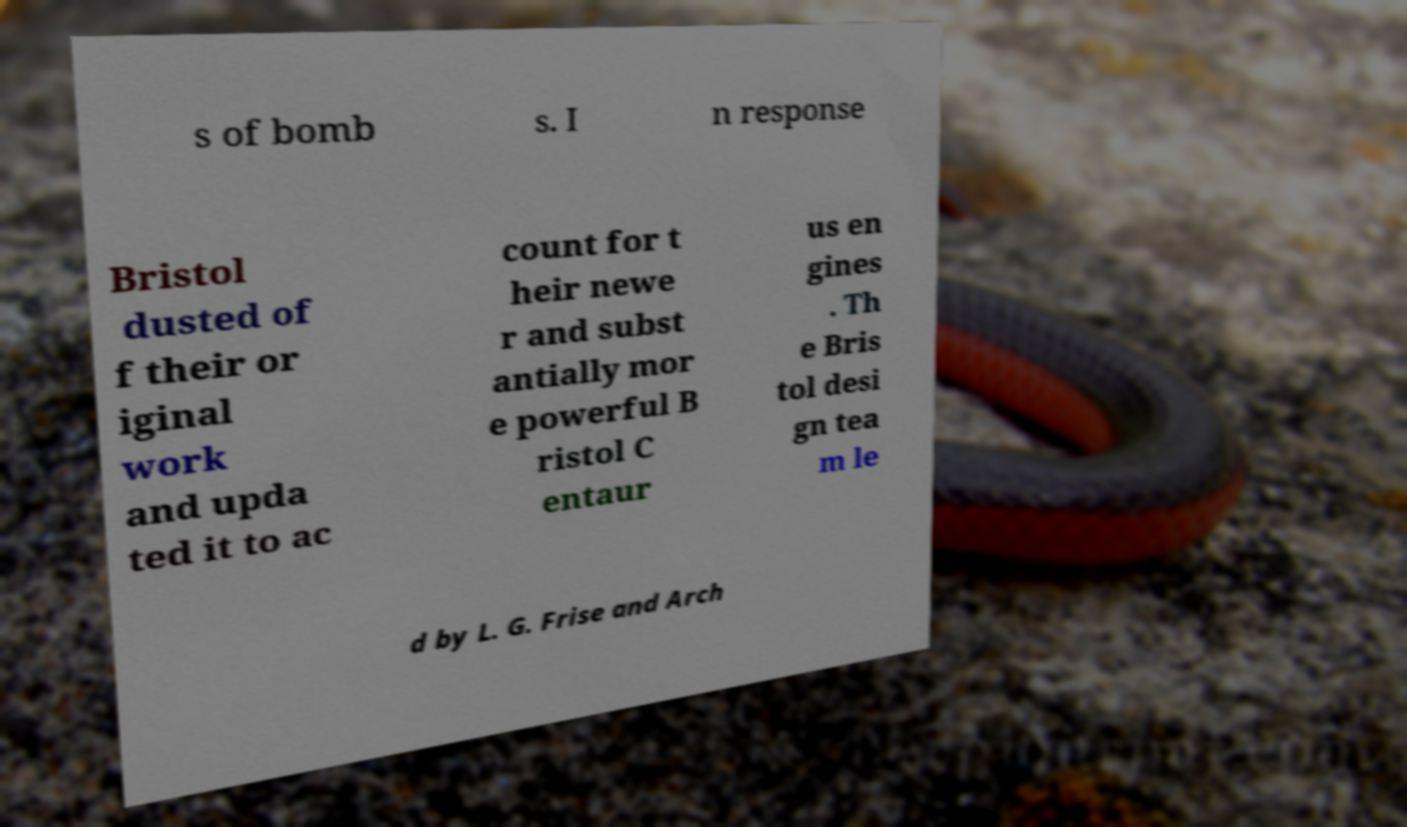Could you extract and type out the text from this image? s of bomb s. I n response Bristol dusted of f their or iginal work and upda ted it to ac count for t heir newe r and subst antially mor e powerful B ristol C entaur us en gines . Th e Bris tol desi gn tea m le d by L. G. Frise and Arch 